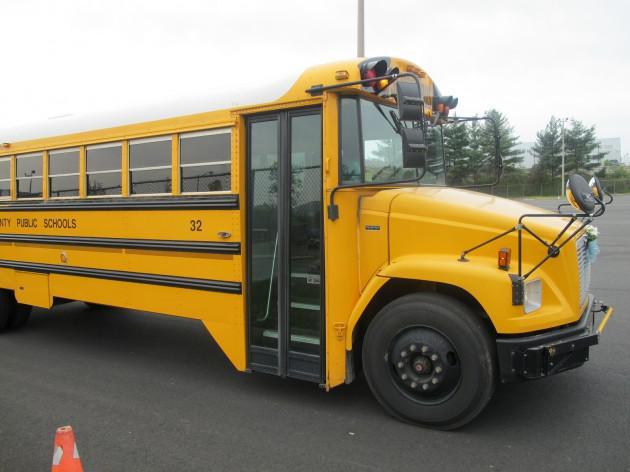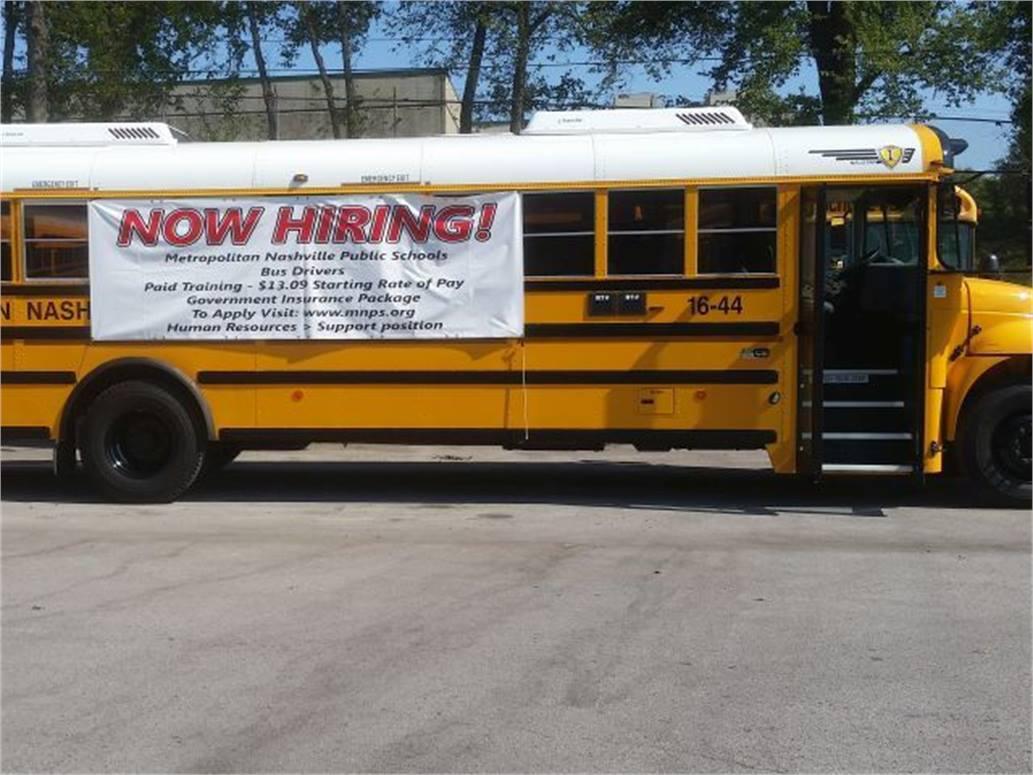The first image is the image on the left, the second image is the image on the right. Examine the images to the left and right. Is the description "In the image to the right, at least one person is standing in front of the open door to the bus." accurate? Answer yes or no. No. The first image is the image on the left, the second image is the image on the right. Considering the images on both sides, is "One image shows one forward-facing flat-fronted bus with at least one person standing at the left, door side, and the other image shows a forward-facing non-flat-front bus with at least one person standing at the left, door side." valid? Answer yes or no. No. 